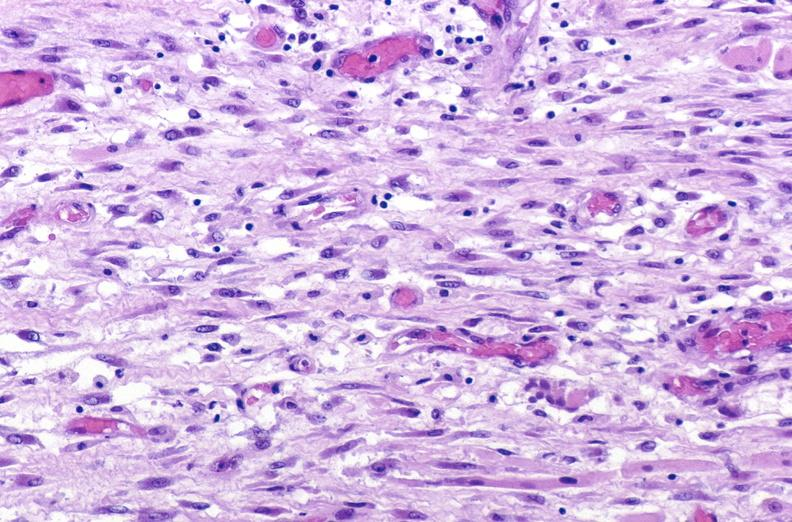s glioma present?
Answer the question using a single word or phrase. No 